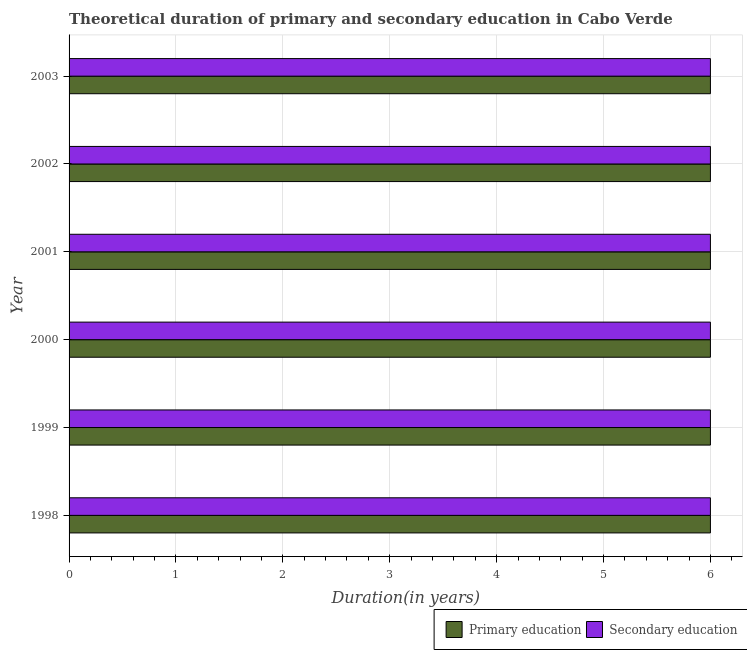How many different coloured bars are there?
Ensure brevity in your answer.  2. How many groups of bars are there?
Offer a very short reply. 6. How many bars are there on the 2nd tick from the top?
Give a very brief answer. 2. In how many cases, is the number of bars for a given year not equal to the number of legend labels?
Provide a succinct answer. 0. Across all years, what is the minimum duration of secondary education?
Offer a terse response. 6. What is the total duration of secondary education in the graph?
Your answer should be compact. 36. What is the average duration of secondary education per year?
Your response must be concise. 6. In the year 2002, what is the difference between the duration of primary education and duration of secondary education?
Give a very brief answer. 0. In how many years, is the duration of secondary education greater than 2.8 years?
Keep it short and to the point. 6. Is the duration of primary education in 1998 less than that in 1999?
Your response must be concise. No. Is the difference between the duration of secondary education in 1999 and 2002 greater than the difference between the duration of primary education in 1999 and 2002?
Offer a very short reply. No. What is the difference between the highest and the second highest duration of secondary education?
Your response must be concise. 0. What is the difference between the highest and the lowest duration of primary education?
Make the answer very short. 0. In how many years, is the duration of secondary education greater than the average duration of secondary education taken over all years?
Provide a short and direct response. 0. What does the 1st bar from the top in 1999 represents?
Provide a succinct answer. Secondary education. What does the 1st bar from the bottom in 2001 represents?
Your answer should be compact. Primary education. How many bars are there?
Keep it short and to the point. 12. How many years are there in the graph?
Provide a succinct answer. 6. What is the difference between two consecutive major ticks on the X-axis?
Keep it short and to the point. 1. Does the graph contain any zero values?
Your answer should be compact. No. Does the graph contain grids?
Keep it short and to the point. Yes. Where does the legend appear in the graph?
Offer a terse response. Bottom right. What is the title of the graph?
Provide a short and direct response. Theoretical duration of primary and secondary education in Cabo Verde. What is the label or title of the X-axis?
Your response must be concise. Duration(in years). What is the label or title of the Y-axis?
Make the answer very short. Year. What is the Duration(in years) in Secondary education in 1999?
Your answer should be compact. 6. What is the Duration(in years) of Primary education in 2001?
Keep it short and to the point. 6. What is the Duration(in years) of Secondary education in 2001?
Provide a succinct answer. 6. What is the Duration(in years) of Primary education in 2002?
Provide a succinct answer. 6. What is the Duration(in years) of Primary education in 2003?
Offer a terse response. 6. What is the Duration(in years) in Secondary education in 2003?
Your answer should be compact. 6. Across all years, what is the maximum Duration(in years) of Secondary education?
Provide a short and direct response. 6. Across all years, what is the minimum Duration(in years) of Primary education?
Your response must be concise. 6. Across all years, what is the minimum Duration(in years) in Secondary education?
Your response must be concise. 6. What is the total Duration(in years) of Primary education in the graph?
Your response must be concise. 36. What is the total Duration(in years) in Secondary education in the graph?
Your answer should be very brief. 36. What is the difference between the Duration(in years) in Primary education in 1998 and that in 1999?
Give a very brief answer. 0. What is the difference between the Duration(in years) of Secondary education in 1998 and that in 1999?
Your answer should be very brief. 0. What is the difference between the Duration(in years) of Primary education in 1998 and that in 2000?
Provide a succinct answer. 0. What is the difference between the Duration(in years) in Secondary education in 1998 and that in 2001?
Ensure brevity in your answer.  0. What is the difference between the Duration(in years) in Primary education in 1998 and that in 2002?
Ensure brevity in your answer.  0. What is the difference between the Duration(in years) in Primary education in 1998 and that in 2003?
Ensure brevity in your answer.  0. What is the difference between the Duration(in years) in Secondary education in 1998 and that in 2003?
Your response must be concise. 0. What is the difference between the Duration(in years) in Secondary education in 1999 and that in 2000?
Ensure brevity in your answer.  0. What is the difference between the Duration(in years) in Secondary education in 1999 and that in 2001?
Make the answer very short. 0. What is the difference between the Duration(in years) of Secondary education in 1999 and that in 2002?
Ensure brevity in your answer.  0. What is the difference between the Duration(in years) in Primary education in 1999 and that in 2003?
Make the answer very short. 0. What is the difference between the Duration(in years) in Secondary education in 2000 and that in 2001?
Provide a short and direct response. 0. What is the difference between the Duration(in years) in Primary education in 2000 and that in 2002?
Your response must be concise. 0. What is the difference between the Duration(in years) of Primary education in 2000 and that in 2003?
Give a very brief answer. 0. What is the difference between the Duration(in years) in Secondary education in 2000 and that in 2003?
Give a very brief answer. 0. What is the difference between the Duration(in years) in Primary education in 2001 and that in 2002?
Your answer should be compact. 0. What is the difference between the Duration(in years) in Primary education in 2001 and that in 2003?
Your answer should be very brief. 0. What is the difference between the Duration(in years) in Secondary education in 2001 and that in 2003?
Offer a very short reply. 0. What is the difference between the Duration(in years) of Primary education in 2002 and that in 2003?
Your response must be concise. 0. What is the difference between the Duration(in years) in Secondary education in 2002 and that in 2003?
Keep it short and to the point. 0. What is the difference between the Duration(in years) in Primary education in 1998 and the Duration(in years) in Secondary education in 2000?
Keep it short and to the point. 0. What is the difference between the Duration(in years) of Primary education in 1998 and the Duration(in years) of Secondary education in 2001?
Make the answer very short. 0. What is the difference between the Duration(in years) in Primary education in 1998 and the Duration(in years) in Secondary education in 2002?
Ensure brevity in your answer.  0. What is the difference between the Duration(in years) of Primary education in 1999 and the Duration(in years) of Secondary education in 2001?
Provide a short and direct response. 0. What is the difference between the Duration(in years) of Primary education in 1999 and the Duration(in years) of Secondary education in 2003?
Offer a terse response. 0. What is the difference between the Duration(in years) of Primary education in 2001 and the Duration(in years) of Secondary education in 2002?
Ensure brevity in your answer.  0. What is the difference between the Duration(in years) of Primary education in 2002 and the Duration(in years) of Secondary education in 2003?
Your answer should be very brief. 0. What is the average Duration(in years) in Primary education per year?
Provide a succinct answer. 6. What is the average Duration(in years) of Secondary education per year?
Ensure brevity in your answer.  6. In the year 2000, what is the difference between the Duration(in years) of Primary education and Duration(in years) of Secondary education?
Your response must be concise. 0. In the year 2001, what is the difference between the Duration(in years) in Primary education and Duration(in years) in Secondary education?
Provide a short and direct response. 0. In the year 2002, what is the difference between the Duration(in years) of Primary education and Duration(in years) of Secondary education?
Your response must be concise. 0. In the year 2003, what is the difference between the Duration(in years) of Primary education and Duration(in years) of Secondary education?
Give a very brief answer. 0. What is the ratio of the Duration(in years) in Secondary education in 1998 to that in 2001?
Provide a short and direct response. 1. What is the ratio of the Duration(in years) in Secondary education in 1999 to that in 2000?
Offer a very short reply. 1. What is the ratio of the Duration(in years) in Secondary education in 1999 to that in 2003?
Provide a short and direct response. 1. What is the ratio of the Duration(in years) of Primary education in 2000 to that in 2001?
Provide a succinct answer. 1. What is the ratio of the Duration(in years) of Secondary education in 2000 to that in 2001?
Provide a succinct answer. 1. What is the ratio of the Duration(in years) of Primary education in 2000 to that in 2002?
Provide a succinct answer. 1. What is the ratio of the Duration(in years) of Secondary education in 2000 to that in 2002?
Your response must be concise. 1. What is the ratio of the Duration(in years) of Primary education in 2000 to that in 2003?
Your answer should be very brief. 1. What is the ratio of the Duration(in years) in Secondary education in 2000 to that in 2003?
Your response must be concise. 1. What is the ratio of the Duration(in years) in Primary education in 2001 to that in 2002?
Your response must be concise. 1. What is the ratio of the Duration(in years) in Primary education in 2001 to that in 2003?
Provide a succinct answer. 1. What is the difference between the highest and the second highest Duration(in years) of Primary education?
Give a very brief answer. 0. What is the difference between the highest and the second highest Duration(in years) in Secondary education?
Give a very brief answer. 0. What is the difference between the highest and the lowest Duration(in years) of Secondary education?
Make the answer very short. 0. 